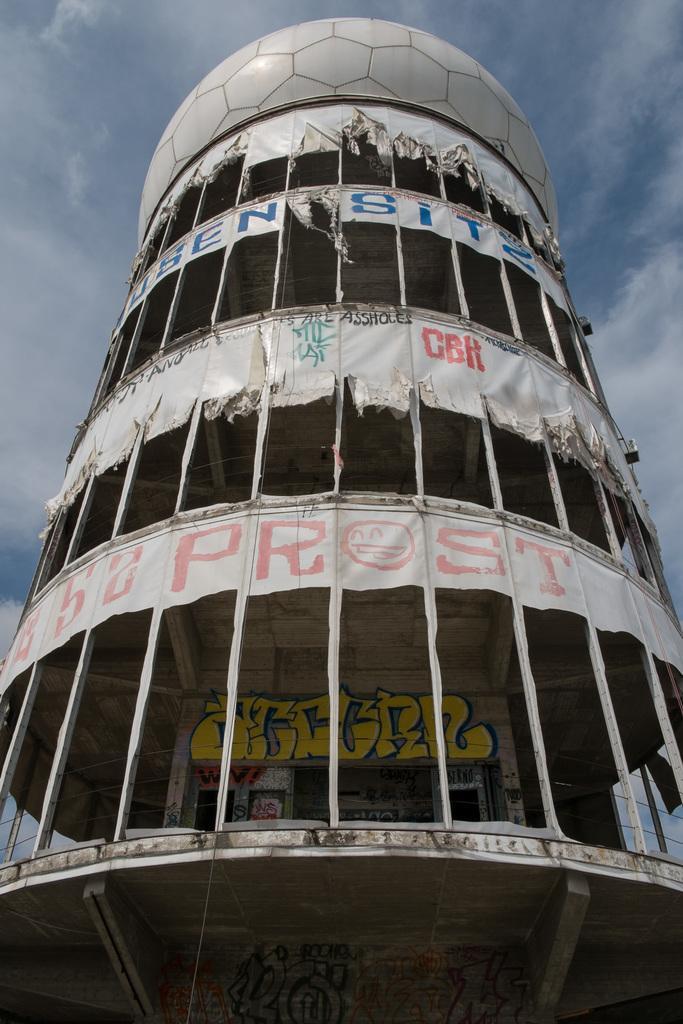How would you summarize this image in a sentence or two? In this picture we can see building, banners and painting on the wall. In the background of the image we can see sky with clouds. 